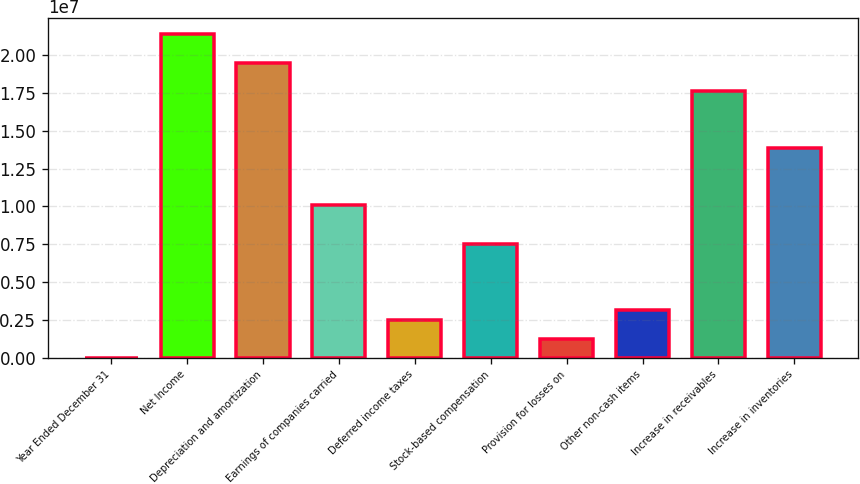<chart> <loc_0><loc_0><loc_500><loc_500><bar_chart><fcel>Year Ended December 31<fcel>Net Income<fcel>Depreciation and amortization<fcel>Earnings of companies carried<fcel>Deferred income taxes<fcel>Stock-based compensation<fcel>Provision for losses on<fcel>Other non-cash items<fcel>Increase in receivables<fcel>Increase in inventories<nl><fcel>2007<fcel>2.13705e+07<fcel>1.94851e+07<fcel>1.00578e+07<fcel>2.51595e+06<fcel>7.54384e+06<fcel>1.25898e+06<fcel>3.14444e+06<fcel>1.75996e+07<fcel>1.38287e+07<nl></chart> 